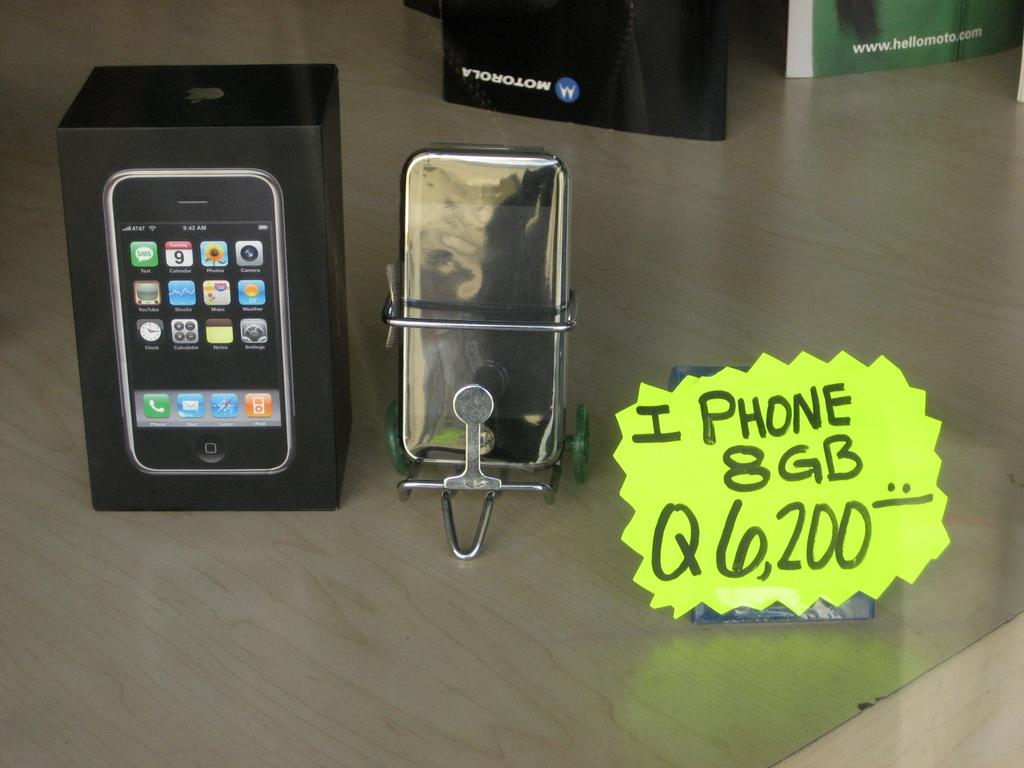<image>
Provide a brief description of the given image. sign for iphone 8 g it looks like an old model 